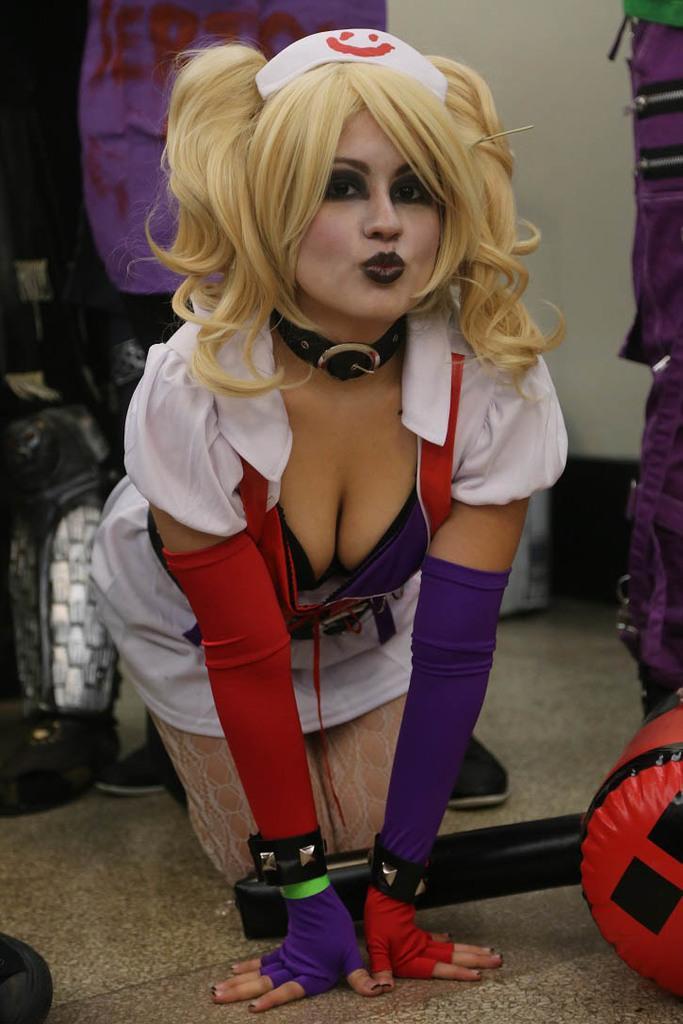Could you give a brief overview of what you see in this image? There is a woman, we can see objects on the floor. In the background we can see wall and there are few things. 